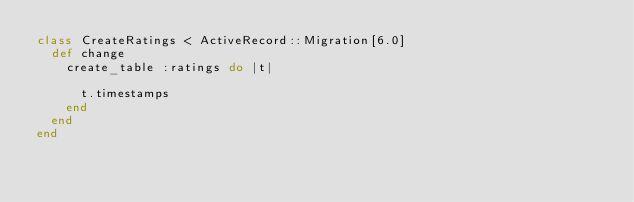Convert code to text. <code><loc_0><loc_0><loc_500><loc_500><_Ruby_>class CreateRatings < ActiveRecord::Migration[6.0]
  def change
    create_table :ratings do |t|

      t.timestamps
    end
  end
end
</code> 